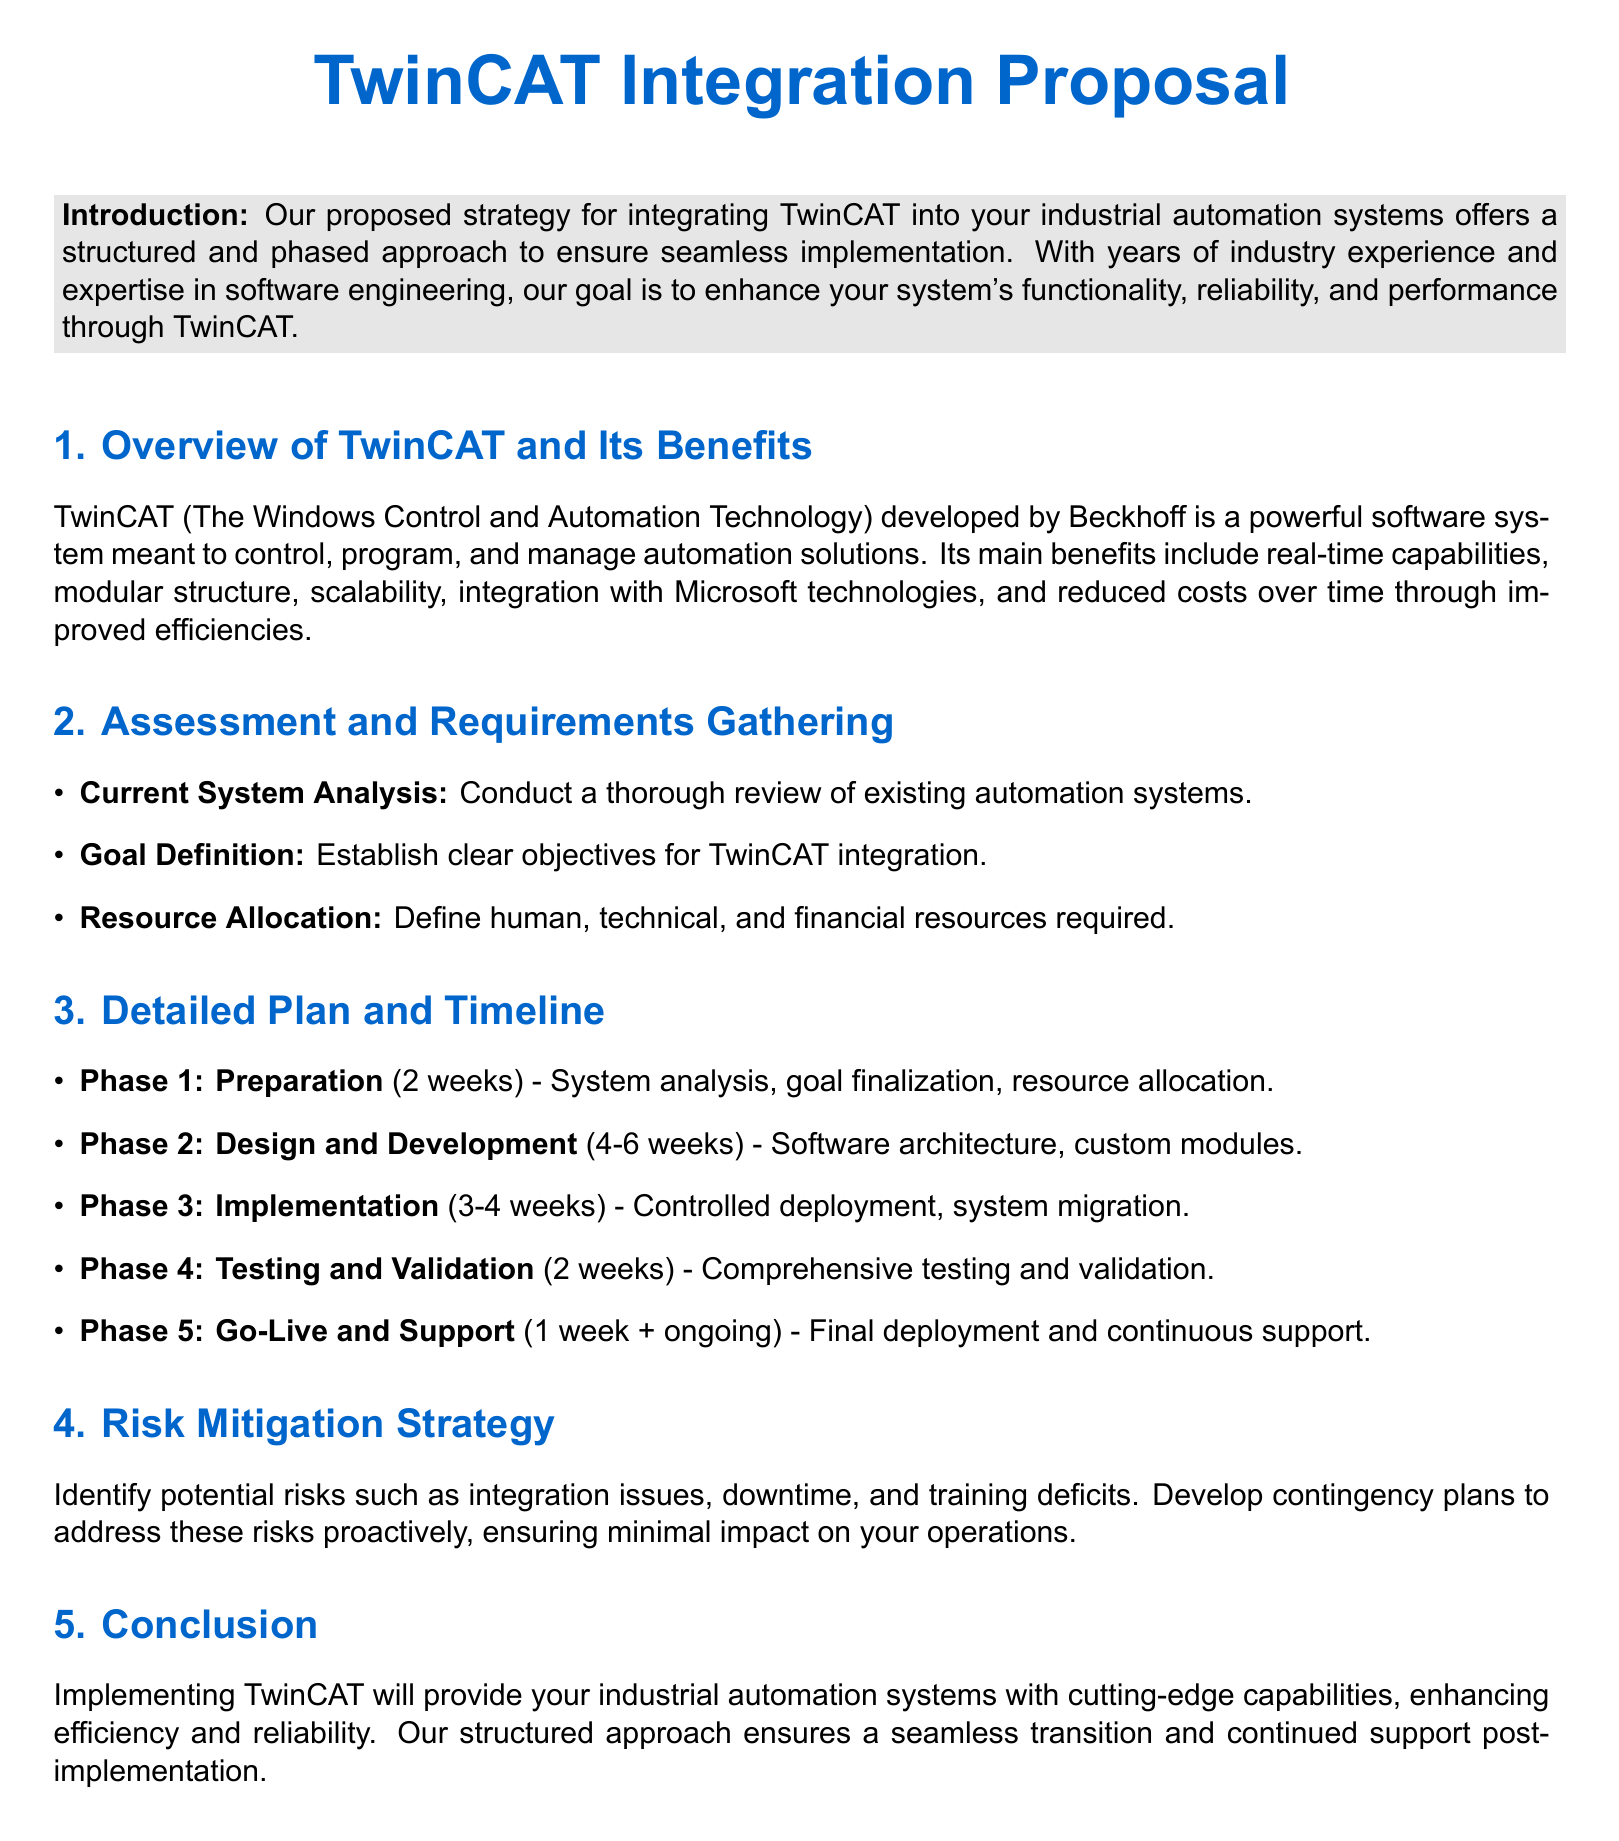What is the primary software system discussed in this proposal? The proposal is centered around TwinCAT, which is mentioned as a powerful software system for industrial automation.
Answer: TwinCAT What phase follows the Design and Development phase? According to the timeline, the phase that comes after Design and Development is Implementation.
Answer: Implementation How long is the Preparation phase scheduled to last? The document specifies that the Preparation phase will take 2 weeks.
Answer: 2 weeks What is one key benefit of TwinCAT mentioned in the proposal? The proposal lists real-time capabilities as one of the main benefits of TwinCAT.
Answer: Real-time capabilities What document section outlines the risks associated with TwinCAT integration? The Risk Mitigation Strategy section discusses potential risks related to integration.
Answer: Risk Mitigation Strategy What is the total duration for the Testing and Validation phase? The Testing and Validation phase is described as lasting for 2 weeks.
Answer: 2 weeks Which company developed TwinCAT? The document attributes the development of TwinCAT to Beckhoff.
Answer: Beckhoff What is the final phase in the detailed implementation plan? The final phase mentioned in the detailed plan is Go-Live and Support.
Answer: Go-Live and Support 